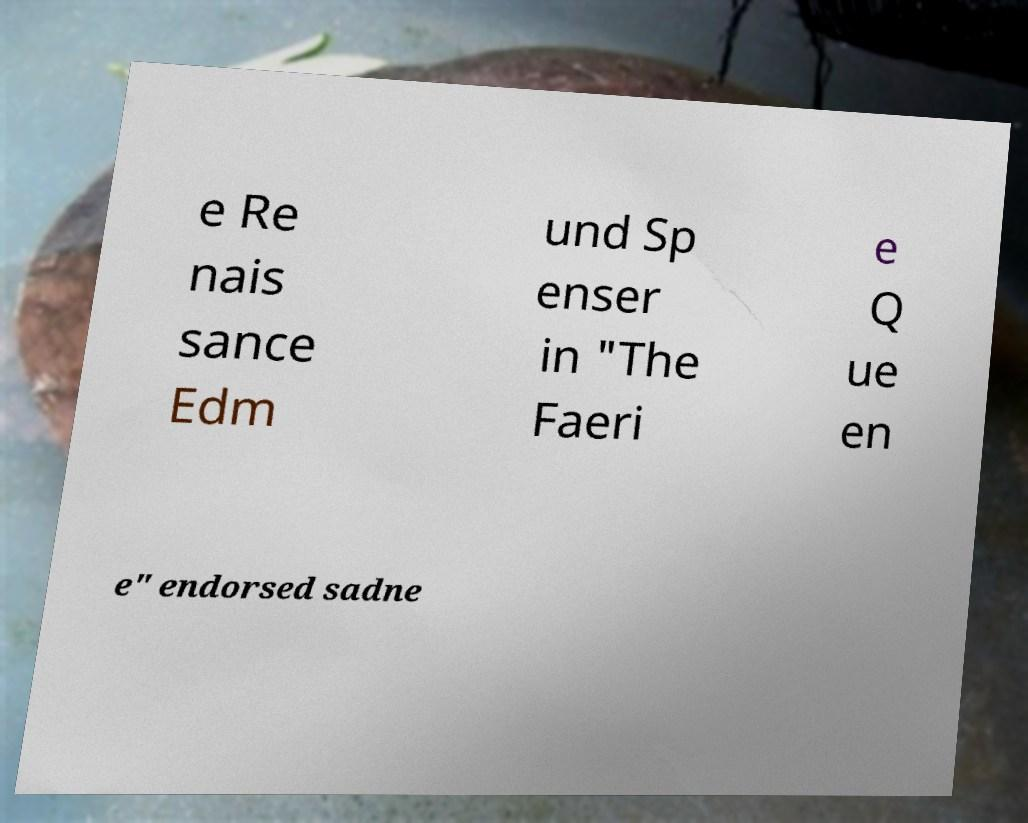Please identify and transcribe the text found in this image. e Re nais sance Edm und Sp enser in "The Faeri e Q ue en e" endorsed sadne 